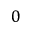Convert formula to latex. <formula><loc_0><loc_0><loc_500><loc_500>0</formula> 